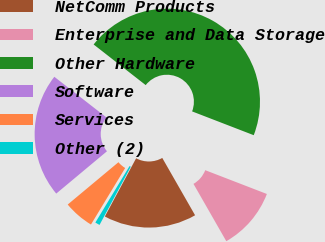Convert chart. <chart><loc_0><loc_0><loc_500><loc_500><pie_chart><fcel>NetComm Products<fcel>Enterprise and Data Storage<fcel>Other Hardware<fcel>Software<fcel>Services<fcel>Other (2)<nl><fcel>16.12%<fcel>10.86%<fcel>45.32%<fcel>21.61%<fcel>5.27%<fcel>0.82%<nl></chart> 